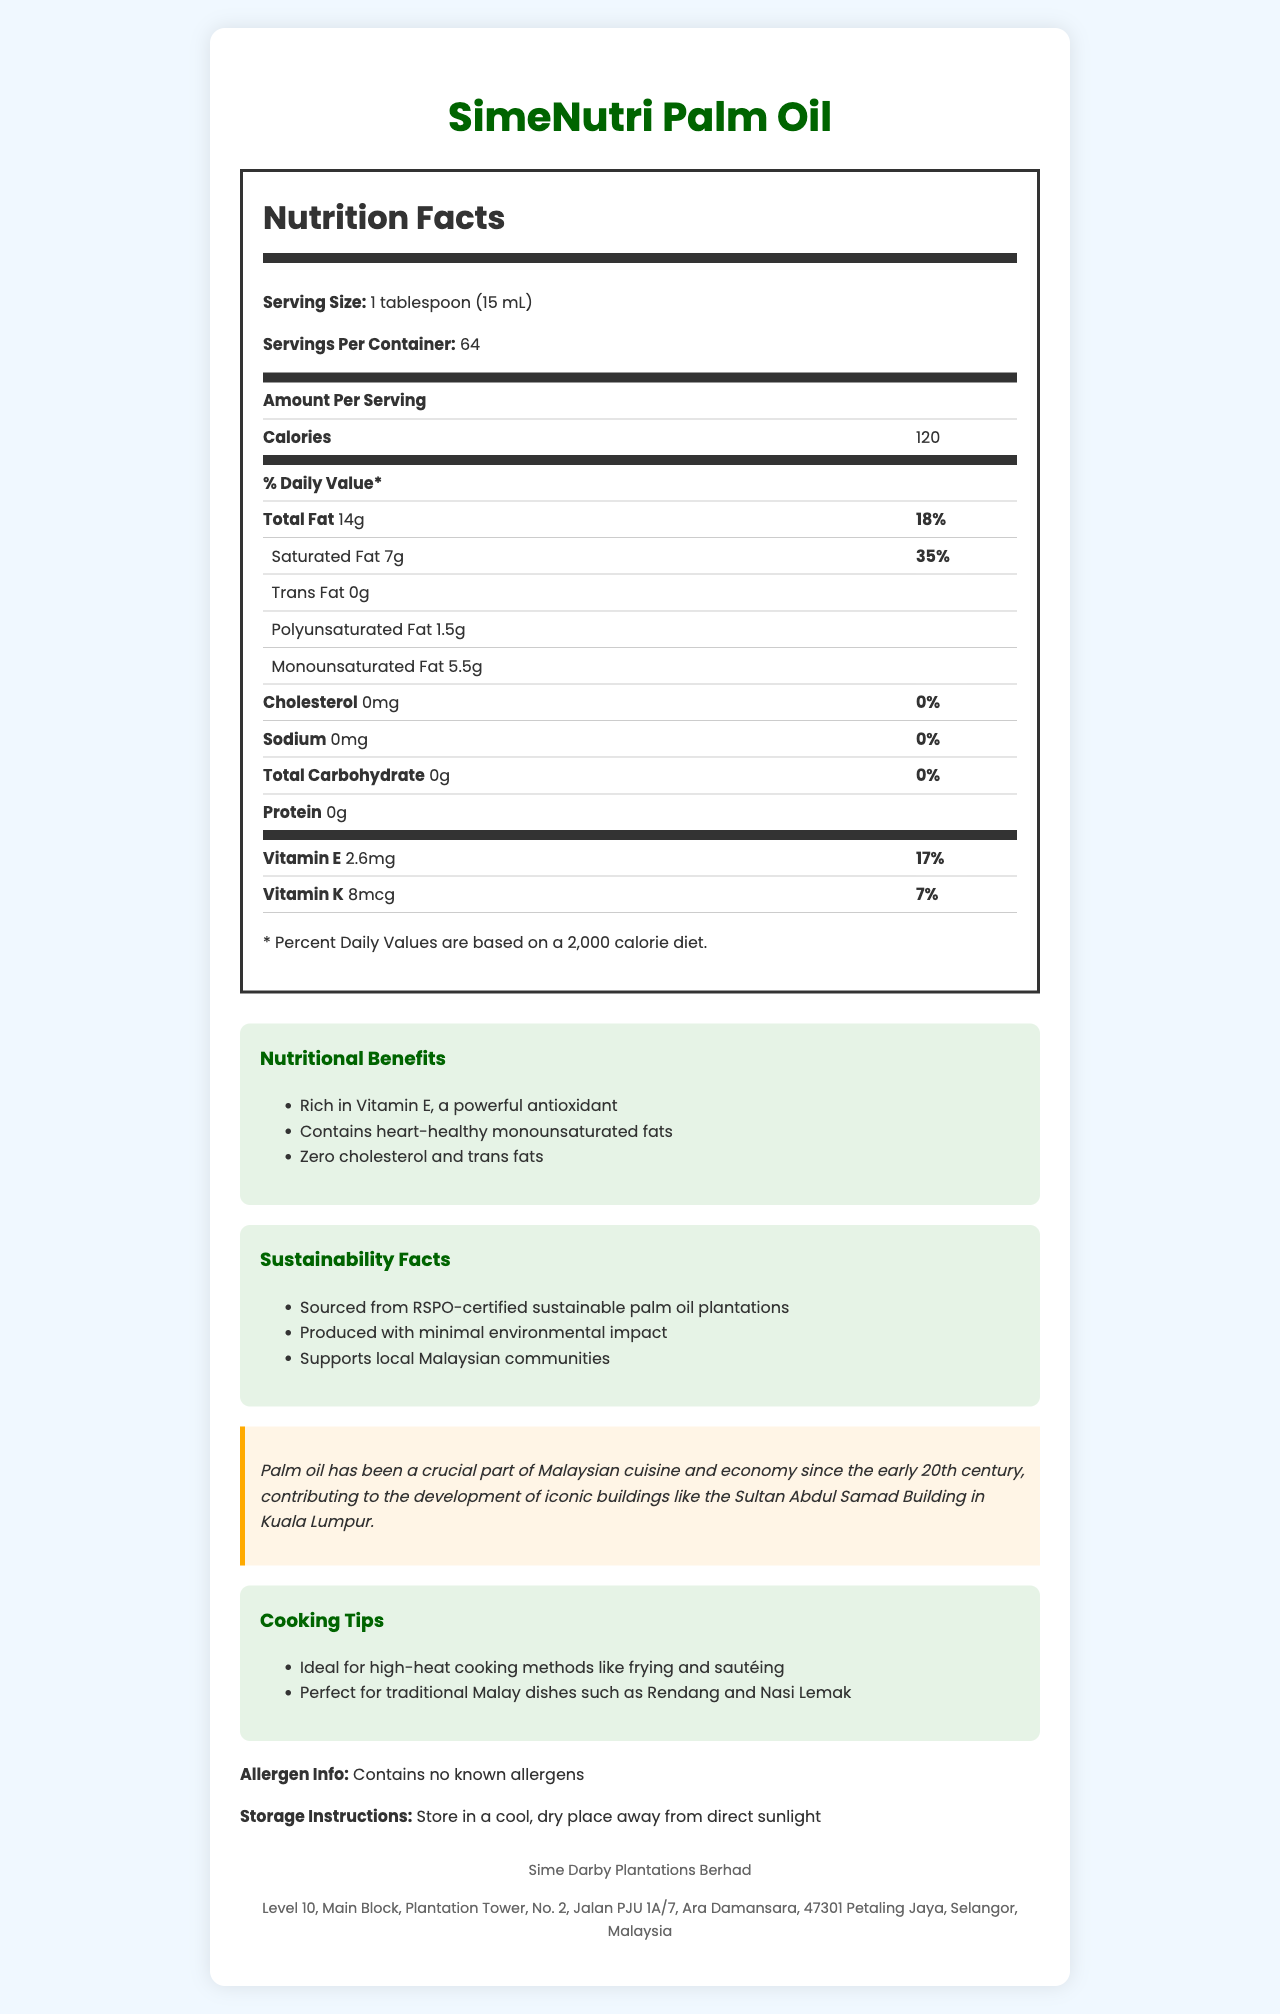what is the serving size for SimeNutri Palm Oil? The serving size is specified at the beginning of the Nutrition Facts section which states "Serving Size: 1 tablespoon (15 mL)".
Answer: 1 tablespoon (15 mL) how many calories are there per serving? The Nutrition Facts table lists calories per serving as 120.
Answer: 120 how much saturated fat does each serving contain? The Nutrition Facts table lists saturated fat amount as 7g per serving.
Answer: 7g is there any cholesterol in SimeNutri Palm Oil? The Nutrition Facts section lists cholesterol content as 0mg.
Answer: No what are the cooking tips provided for SimeNutri Palm Oil? The Cooking Tips section provides these specific tips.
Answer: Ideal for high-heat cooking methods like frying and sautéing; Perfect for traditional Malay dishes such as Rendang and Nasi Lemak how many servings are there per container? The Nutrition Facts section specifies "Servings Per Container: 64".
Answer: 64 which type of fat is SimeNutri Palm Oil highest in? A. Saturated Fat B. Polyunsaturated Fat C. Monounsaturated Fat The Nutrition Facts table lists 7g of Saturated Fat, 1.5g of Polyunsaturated Fat, and 5.5g of Monounsaturated Fat, making Saturated Fat the highest.
Answer: A what percentage of the daily value for Vitamin E does one serving provide? A. 10% B. 17% C. 20% D. 25% The Nutrition Facts section lists Vitamin E content as 17% of the daily value.
Answer: B is SimeNutri Palm Oil suitable for individuals with allergies? The document specifies that it contains no known allergens.
Answer: Yes summarize the key points of the document. The document summarizes nutritional benefits, the sustainability of its sourcing, company information, historical notes, and specific usage tips, providing an overview of the product's quality and benefits.
Answer: SimeNutri Palm Oil is a palm oil-based cooking oil by Sime Darby Plantations Berhad, rich in Vitamin E and heart-healthy monounsaturated fats, containing zero cholesterol and trans fats. It's sourced sustainably from RSPO-certified plantations. The oil supports local Malaysian communities, has a total calorie count of 120 per tablespoon, and is ideal for high-heat cooking methods like frying and sautéing, especially for traditional Malay dishes. does SimeNutri Palm Oil have trans fats? The Nutrition Facts section lists Trans Fat as 0g per serving.
Answer: No what is the address of Sime Darby Plantations Berhad? The address is provided in the company info section.
Answer: Level 10, Main Block, Plantation Tower, No. 2, Jalan PJU 1A/7, Ara Damansara, 47301 Petaling Jaya, Selangor, Malaysia why is palm oil significant in Malaysian history? The historical note mentions this significance.
Answer: Palm oil has contributed to Malaysian cuisine and economy since the early 20th century, aiding in the development of iconic buildings like the Sultan Abdul Samad Building in Kuala Lumpur. how are sustainability efforts highlighted in the document? The Sustainability Facts section provides these details.
Answer: The document mentions that SimeNutri Palm Oil is sourced from RSPO-certified sustainable plantations, produced with minimal environmental impact, and supports local Malaysian communities. how much sodium does SimeNutri Palm Oil contain? The Nutrition Facts section lists sodium content as 0mg.
Answer: 0mg does the document mention the price of SimeNutri Palm Oil? The document does not provide any information regarding the price.
Answer: Not enough information 